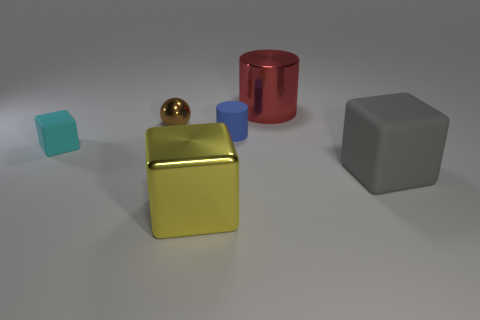What shape is the rubber thing that is behind the small thing on the left side of the brown shiny ball?
Ensure brevity in your answer.  Cylinder. There is a tiny blue matte cylinder; how many tiny matte things are in front of it?
Keep it short and to the point. 1. What color is the large cylinder that is made of the same material as the small ball?
Provide a succinct answer. Red. Do the red cylinder and the cube behind the big gray rubber block have the same size?
Make the answer very short. No. What is the size of the blue rubber cylinder in front of the big object behind the rubber cube that is on the right side of the ball?
Offer a terse response. Small. How many rubber things are either yellow cubes or large green objects?
Make the answer very short. 0. The large thing that is in front of the big gray rubber thing is what color?
Provide a short and direct response. Yellow. What is the shape of the blue matte object that is the same size as the metal sphere?
Provide a short and direct response. Cylinder. There is a big rubber object; does it have the same color as the rubber cube left of the big yellow cube?
Keep it short and to the point. No. How many things are blocks left of the tiny shiny ball or blocks to the right of the cyan block?
Keep it short and to the point. 3. 